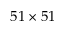<formula> <loc_0><loc_0><loc_500><loc_500>5 1 \times 5 1</formula> 